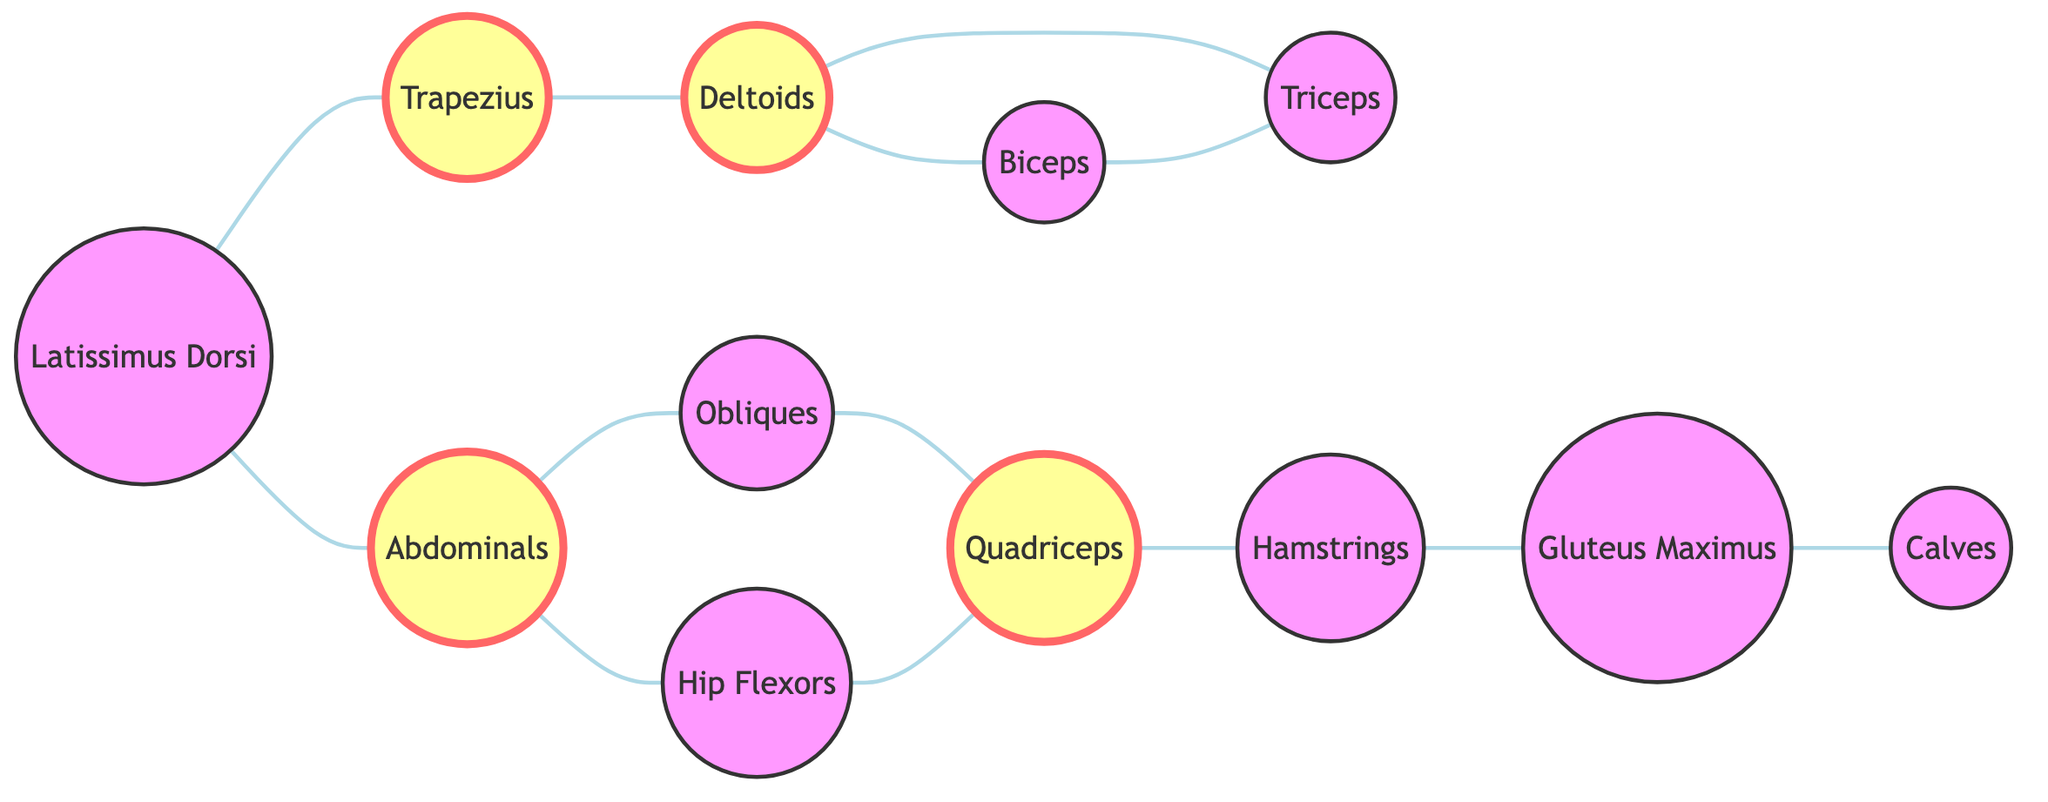What is the total number of nodes in the graph? The graph lists all the unique muscle groups involved in Latin dance. By counting each of the entries under "nodes," we find that there are 12 muscle groups total.
Answer: 12 Which muscle group is directly connected to the Deltoids? Tracing the edges connected to the Deltoids node, we see it is directly linked to both the Biceps and Triceps. The question asks for any single connected muscle, so either of these works as an answer.
Answer: Biceps How many edges are connected to the Abdominals? By reviewing the connections of the Abdominals node, we can see three edges leading to it from Trapezius, Obliques, and Hip Flexors, illustrating its interaction with multiple muscle groups.
Answer: 3 Which muscle group has the most connections? Evaluating the connections, we find that the Deltoids has three connections (to Biceps, Triceps, and Trapezius). Abdominals also has three, connected to Latissimus Dorsi, Obliques, and Hip Flexors, but no other nodes exceed this count. Thus, both Abdominals and Deltoids tie for the most connections.
Answer: Deltoids If the Gluteus Maximus contracts, which muscle group will it directly interact with? Looking at the edges, the Gluteus Maximus is connected directly to the Hamstrings. Therefore, a contraction there will directly influence the Hamstrings.
Answer: Hamstrings What are the three muscles that the Latissimus Dorsi connects to? Following the edges from the Latissimus Dorsi node, we see that it is connected to the Trapezius, Abdominals, and indirectly cooperates through the strength of the Trapezius and the force generated in the Abdominals, leading to a broader interaction pattern. Therefore, these three muscle groups are involved.
Answer: Trapezius, Abdominals Which muscle group is only indirectly connected to the Obliques? Obliques connect to Quadriceps directly, but are linked to Abdominals (and subsequently to other muscle groups) rather than directly. The Quadriceps can be deemed as indirectly linked via the Obliques since it does not connect back to the core cluster.
Answer: Quadriceps How many muscle groups are interlinked with the Quadriceps? The Quadriceps has two edges coming out – one to the Hamstrings and one to the Obliques. Counting these leaves us with two direct connections from the Quadriceps.
Answer: 2 